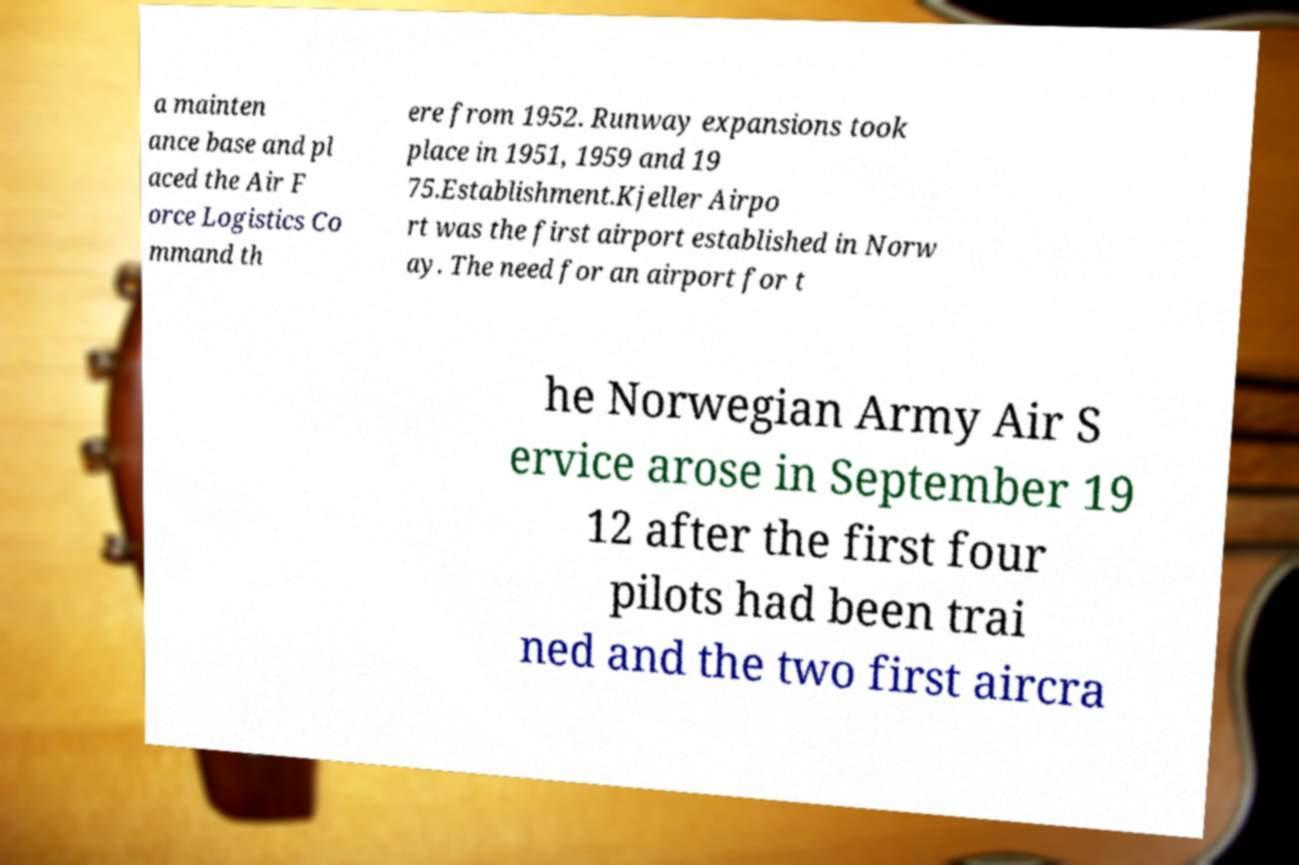Can you read and provide the text displayed in the image?This photo seems to have some interesting text. Can you extract and type it out for me? a mainten ance base and pl aced the Air F orce Logistics Co mmand th ere from 1952. Runway expansions took place in 1951, 1959 and 19 75.Establishment.Kjeller Airpo rt was the first airport established in Norw ay. The need for an airport for t he Norwegian Army Air S ervice arose in September 19 12 after the first four pilots had been trai ned and the two first aircra 